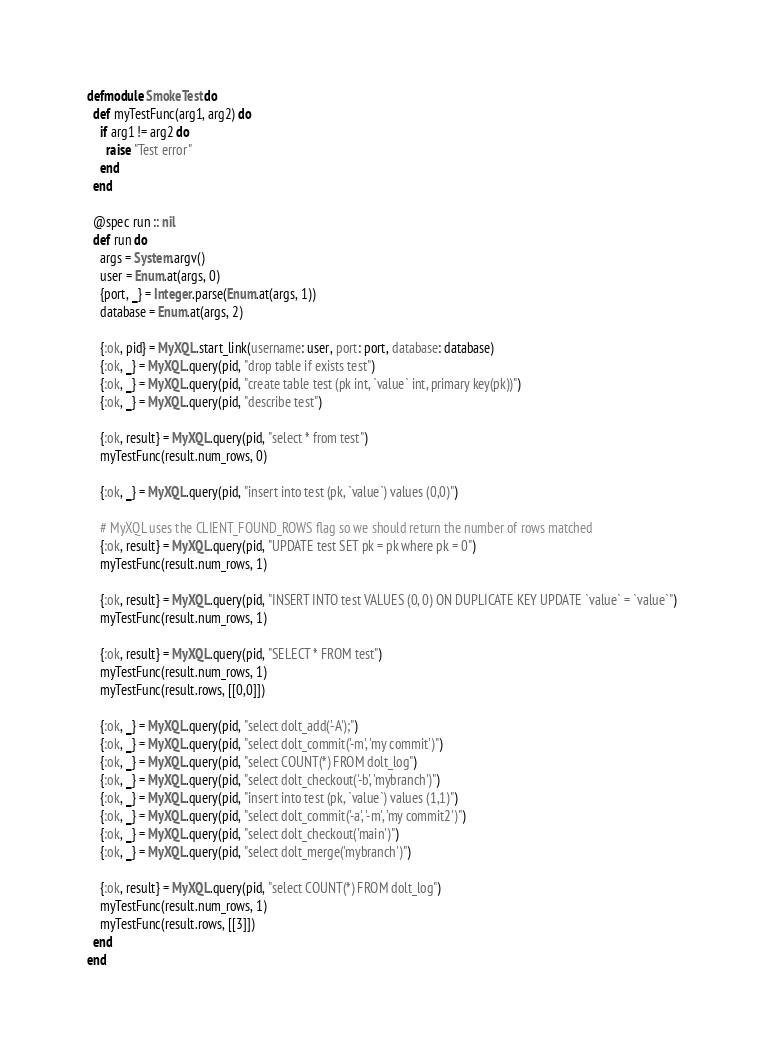<code> <loc_0><loc_0><loc_500><loc_500><_Elixir_>defmodule SmokeTest do
  def myTestFunc(arg1, arg2) do
    if arg1 != arg2 do
      raise "Test error"
    end
  end

  @spec run :: nil
  def run do
    args = System.argv()
    user = Enum.at(args, 0)
    {port, _} = Integer.parse(Enum.at(args, 1))
    database = Enum.at(args, 2)

    {:ok, pid} = MyXQL.start_link(username: user, port: port, database: database)
    {:ok, _} = MyXQL.query(pid, "drop table if exists test")
    {:ok, _} = MyXQL.query(pid, "create table test (pk int, `value` int, primary key(pk))")
    {:ok, _} = MyXQL.query(pid, "describe test")

    {:ok, result} = MyXQL.query(pid, "select * from test")
    myTestFunc(result.num_rows, 0)

    {:ok, _} = MyXQL.query(pid, "insert into test (pk, `value`) values (0,0)")

    # MyXQL uses the CLIENT_FOUND_ROWS flag so we should return the number of rows matched
    {:ok, result} = MyXQL.query(pid, "UPDATE test SET pk = pk where pk = 0")
    myTestFunc(result.num_rows, 1)

    {:ok, result} = MyXQL.query(pid, "INSERT INTO test VALUES (0, 0) ON DUPLICATE KEY UPDATE `value` = `value`")
    myTestFunc(result.num_rows, 1)

    {:ok, result} = MyXQL.query(pid, "SELECT * FROM test")
    myTestFunc(result.num_rows, 1)
    myTestFunc(result.rows, [[0,0]])

    {:ok, _} = MyXQL.query(pid, "select dolt_add('-A');")
    {:ok, _} = MyXQL.query(pid, "select dolt_commit('-m', 'my commit')")
    {:ok, _} = MyXQL.query(pid, "select COUNT(*) FROM dolt_log")
    {:ok, _} = MyXQL.query(pid, "select dolt_checkout('-b', 'mybranch')")
    {:ok, _} = MyXQL.query(pid, "insert into test (pk, `value`) values (1,1)")
    {:ok, _} = MyXQL.query(pid, "select dolt_commit('-a', '-m', 'my commit2')")
    {:ok, _} = MyXQL.query(pid, "select dolt_checkout('main')")
    {:ok, _} = MyXQL.query(pid, "select dolt_merge('mybranch')")

    {:ok, result} = MyXQL.query(pid, "select COUNT(*) FROM dolt_log")
    myTestFunc(result.num_rows, 1)
    myTestFunc(result.rows, [[3]])
  end
end
</code> 